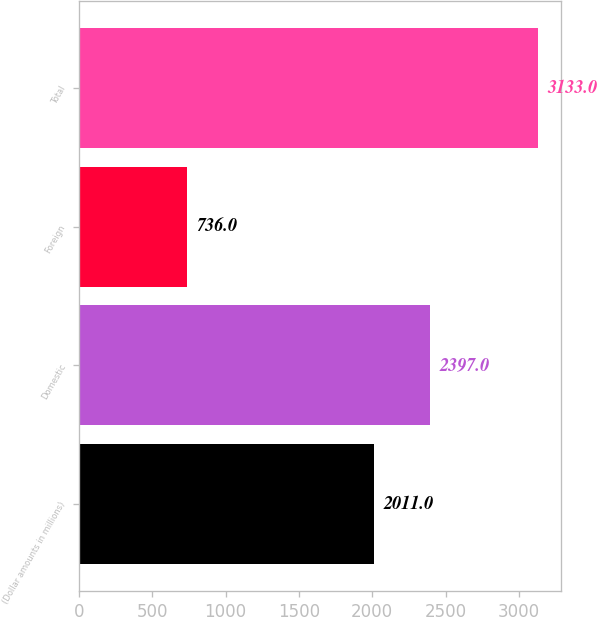<chart> <loc_0><loc_0><loc_500><loc_500><bar_chart><fcel>(Dollar amounts in millions)<fcel>Domestic<fcel>Foreign<fcel>Total<nl><fcel>2011<fcel>2397<fcel>736<fcel>3133<nl></chart> 